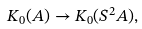<formula> <loc_0><loc_0><loc_500><loc_500>K _ { 0 } ( A ) \to K _ { 0 } ( S ^ { 2 } A ) ,</formula> 